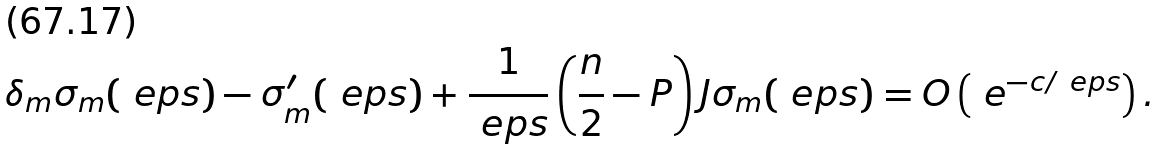Convert formula to latex. <formula><loc_0><loc_0><loc_500><loc_500>\delta _ { m } \sigma _ { m } ( \ e p s ) - \sigma _ { m } ^ { \prime } ( \ e p s ) + \frac { 1 } { \ e p s } \left ( \frac { n } { 2 } - P \right ) J \sigma _ { m } ( \ e p s ) = O \left ( \ e ^ { - c / \ e p s } \right ) .</formula> 